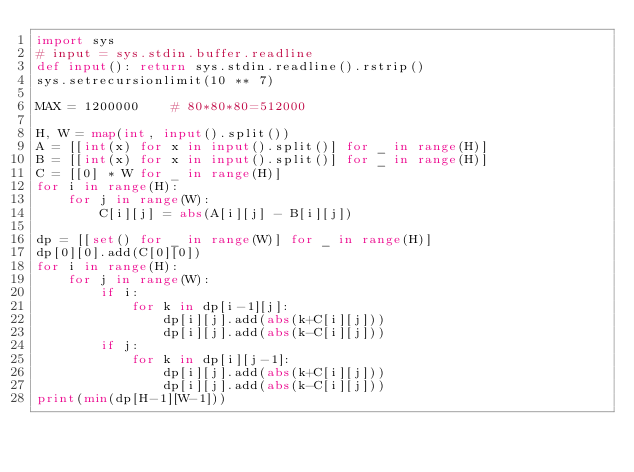Convert code to text. <code><loc_0><loc_0><loc_500><loc_500><_Python_>import sys
# input = sys.stdin.buffer.readline
def input(): return sys.stdin.readline().rstrip()
sys.setrecursionlimit(10 ** 7)

MAX = 1200000    # 80*80*80=512000

H, W = map(int, input().split())
A = [[int(x) for x in input().split()] for _ in range(H)]
B = [[int(x) for x in input().split()] for _ in range(H)]
C = [[0] * W for _ in range(H)]
for i in range(H):
    for j in range(W):
        C[i][j] = abs(A[i][j] - B[i][j])

dp = [[set() for _ in range(W)] for _ in range(H)]
dp[0][0].add(C[0][0])
for i in range(H):
    for j in range(W):
        if i:
            for k in dp[i-1][j]:
                dp[i][j].add(abs(k+C[i][j]))
                dp[i][j].add(abs(k-C[i][j]))
        if j:
            for k in dp[i][j-1]:
                dp[i][j].add(abs(k+C[i][j]))
                dp[i][j].add(abs(k-C[i][j]))
print(min(dp[H-1][W-1]))
</code> 